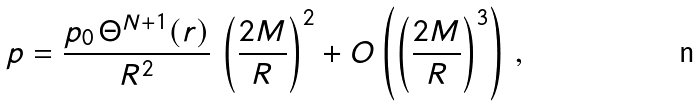Convert formula to latex. <formula><loc_0><loc_0><loc_500><loc_500>p = \frac { p _ { 0 } \, \Theta ^ { N + 1 } ( r ) } { R ^ { 2 } } \, \left ( \frac { 2 M } { R } \right ) ^ { 2 } + O \left ( \left ( \frac { 2 M } { R } \right ) ^ { 3 } \right ) \, ,</formula> 